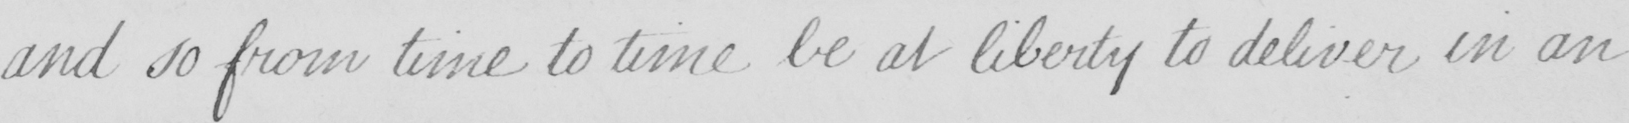Can you read and transcribe this handwriting? and so from time to time be at liberty to deliver in an 